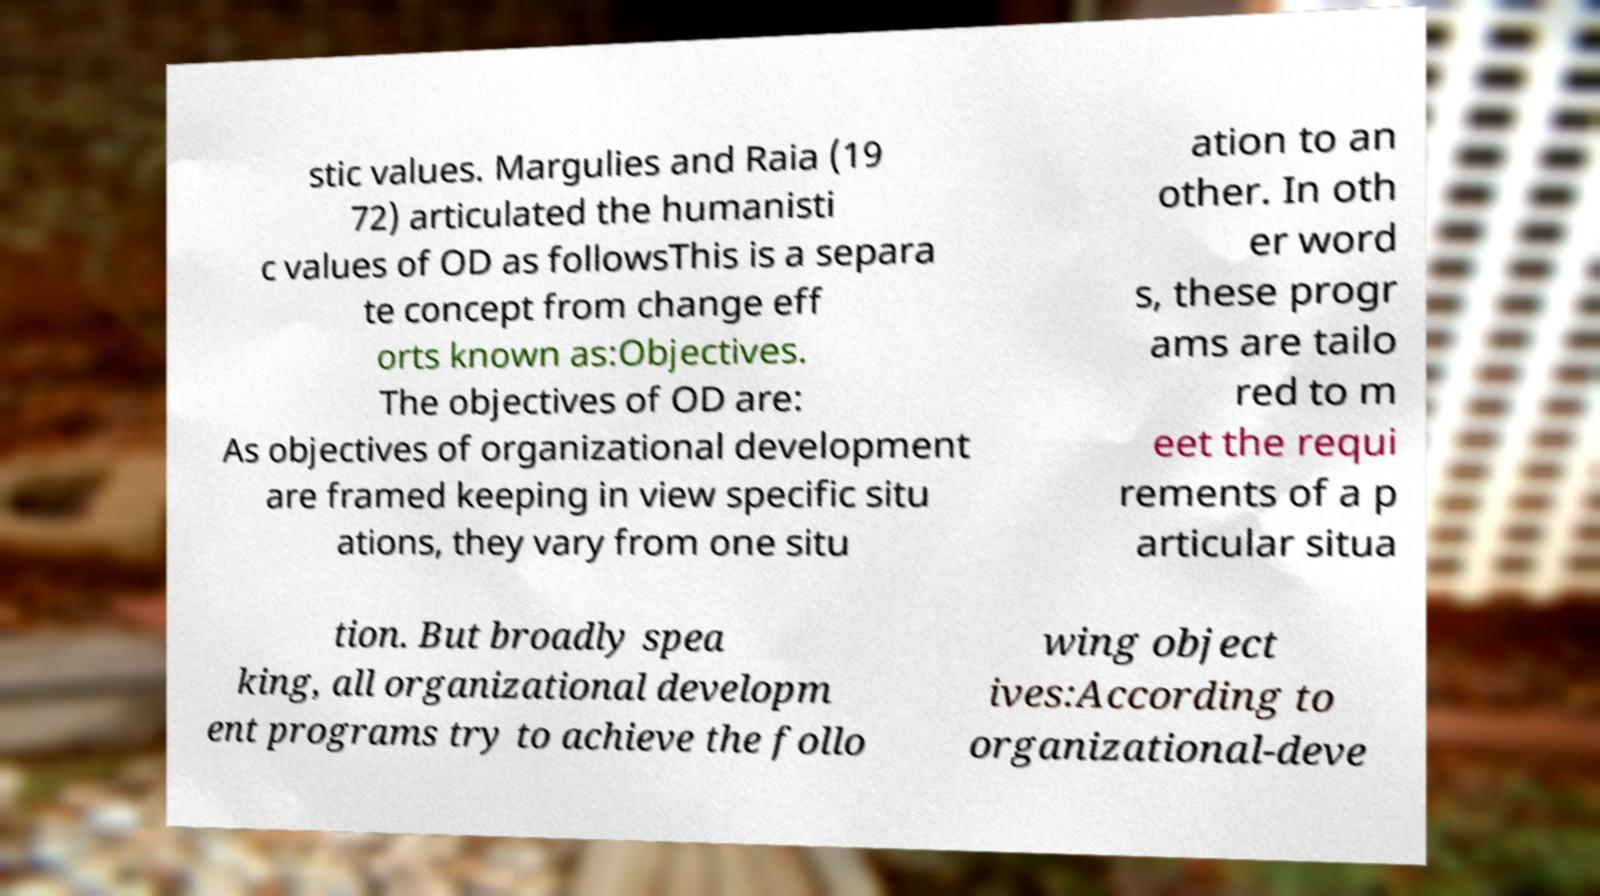Could you extract and type out the text from this image? stic values. Margulies and Raia (19 72) articulated the humanisti c values of OD as followsThis is a separa te concept from change eff orts known as:Objectives. The objectives of OD are: As objectives of organizational development are framed keeping in view specific situ ations, they vary from one situ ation to an other. In oth er word s, these progr ams are tailo red to m eet the requi rements of a p articular situa tion. But broadly spea king, all organizational developm ent programs try to achieve the follo wing object ives:According to organizational-deve 